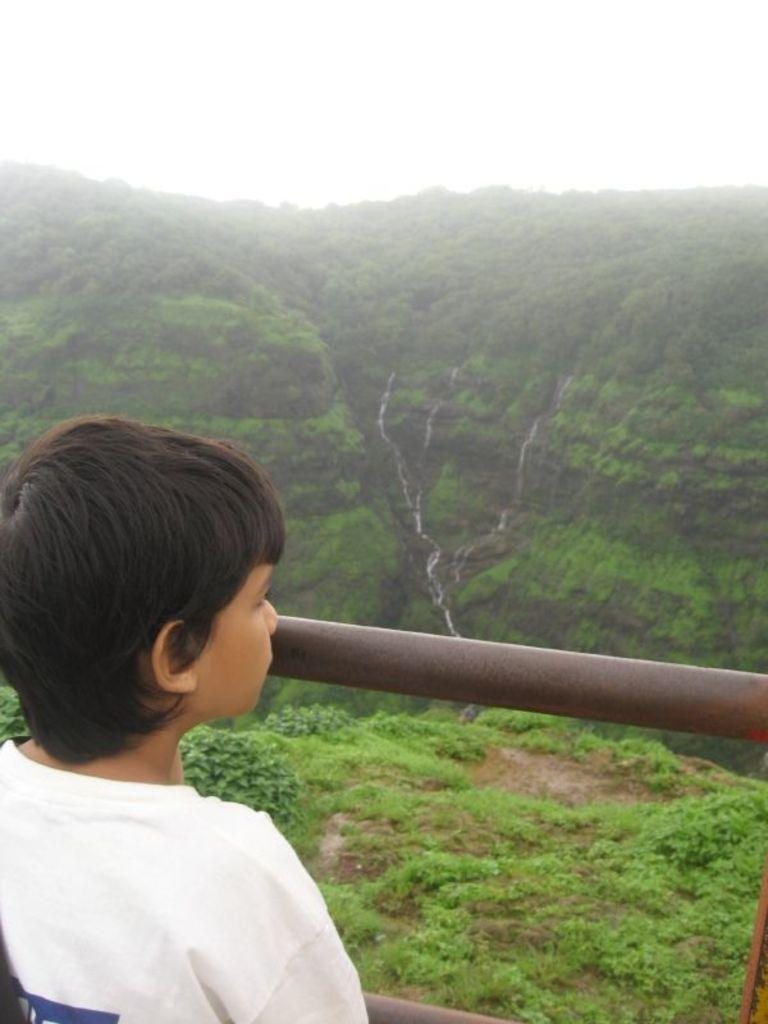What is the main subject of the image? There is a child in the image. What is the child wearing? The child is wearing a white T-shirt. Where is the child standing in relation to the fence? The child is standing near a fence. What can be seen in the background of the image? There are trees, hills, a waterfall, and the sky visible in the background of the image. What type of yarn is the child using to climb the waterfall in the image? There is no yarn present in the image, and the child is not climbing the waterfall. 